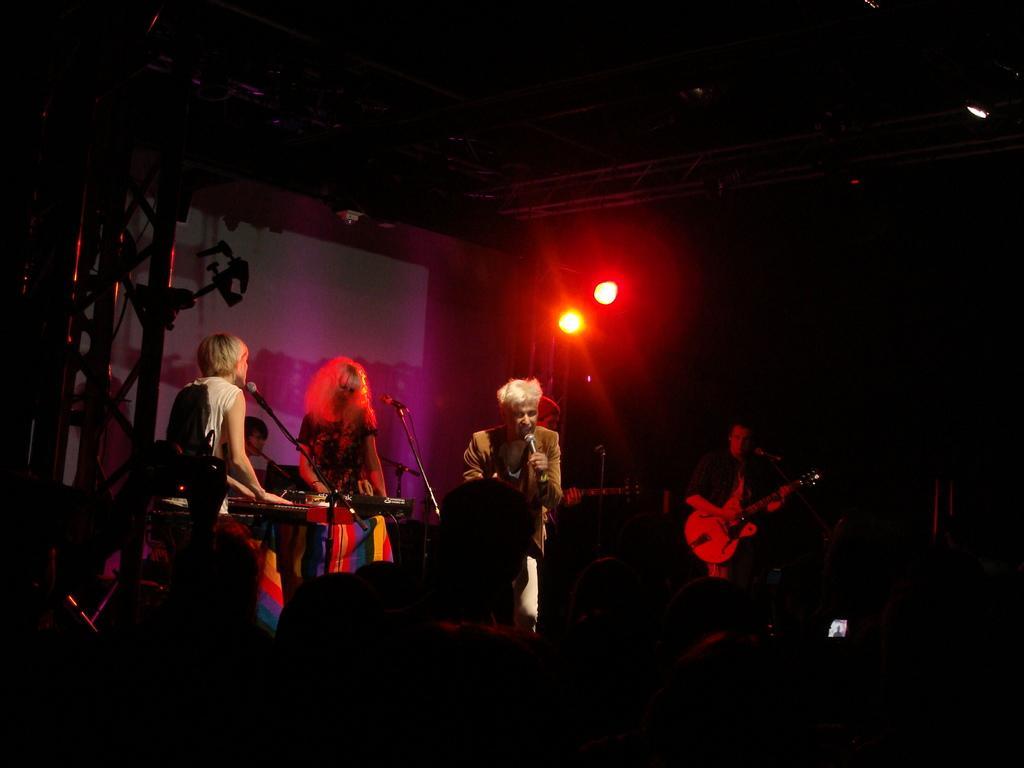Please provide a concise description of this image. In this image we can see persons standing on the floor and holding musical instruments in their hands and mics are placed in front of them. In the background we can see electric lights, iron grills and curtain. 